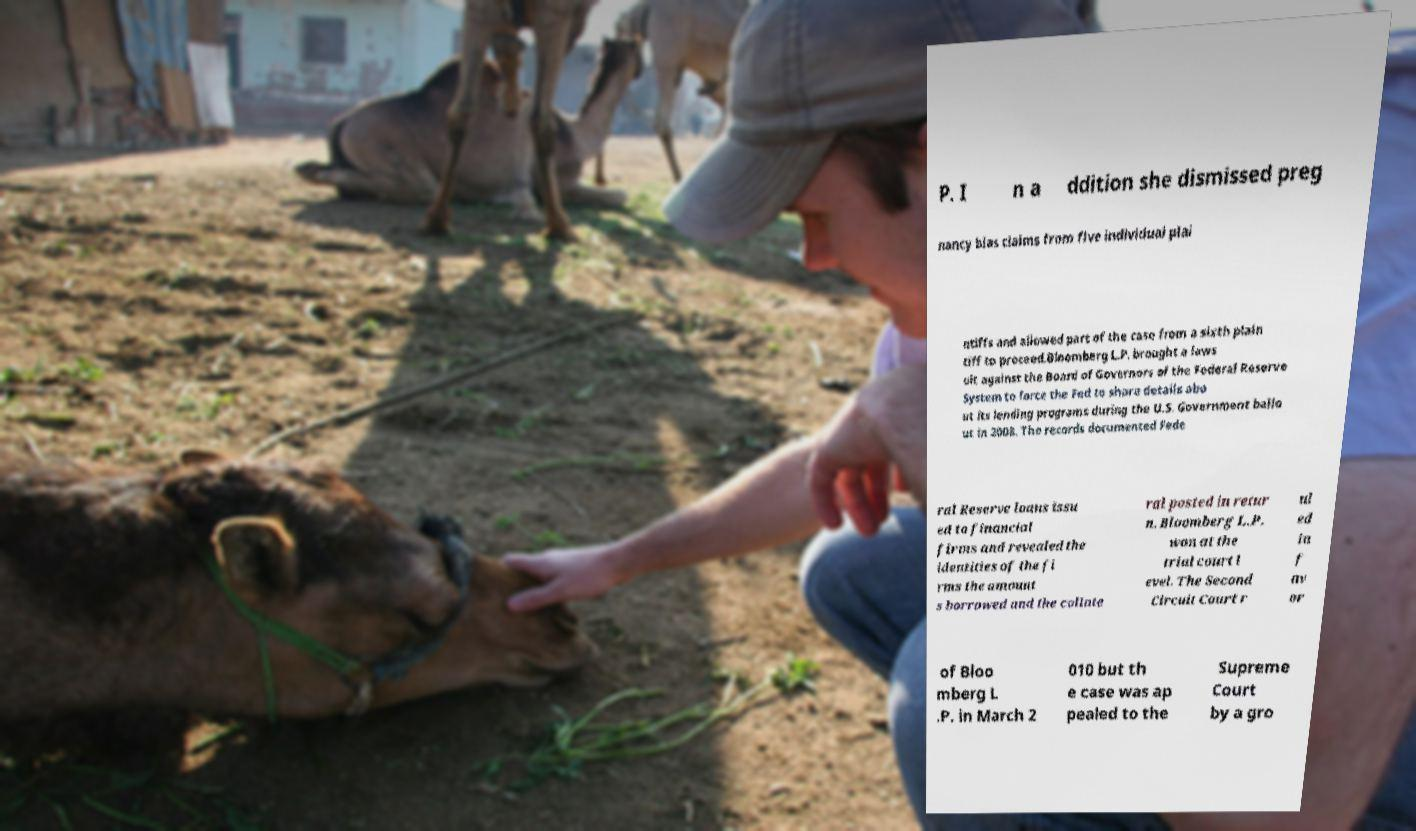Could you assist in decoding the text presented in this image and type it out clearly? P. I n a ddition she dismissed preg nancy bias claims from five individual plai ntiffs and allowed part of the case from a sixth plain tiff to proceed.Bloomberg L.P. brought a laws uit against the Board of Governors of the Federal Reserve System to force the Fed to share details abo ut its lending programs during the U.S. Government bailo ut in 2008. The records documented Fede ral Reserve loans issu ed to financial firms and revealed the identities of the fi rms the amount s borrowed and the collate ral posted in retur n. Bloomberg L.P. won at the trial court l evel. The Second Circuit Court r ul ed in f av or of Bloo mberg L .P. in March 2 010 but th e case was ap pealed to the Supreme Court by a gro 